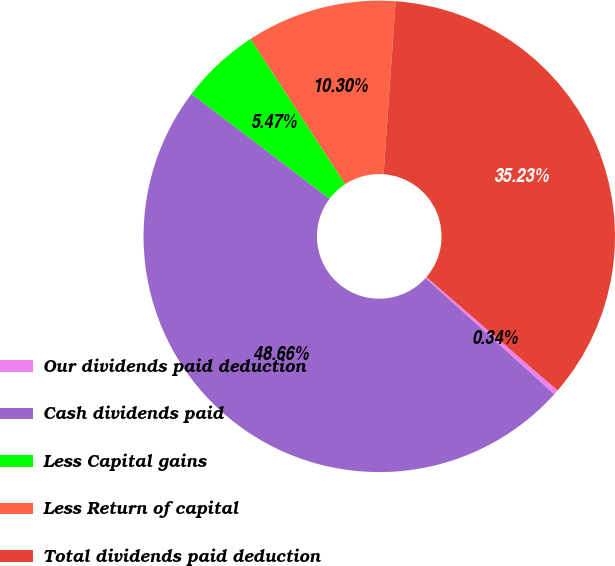<chart> <loc_0><loc_0><loc_500><loc_500><pie_chart><fcel>Our dividends paid deduction<fcel>Cash dividends paid<fcel>Less Capital gains<fcel>Less Return of capital<fcel>Total dividends paid deduction<nl><fcel>0.34%<fcel>48.66%<fcel>5.47%<fcel>10.3%<fcel>35.23%<nl></chart> 